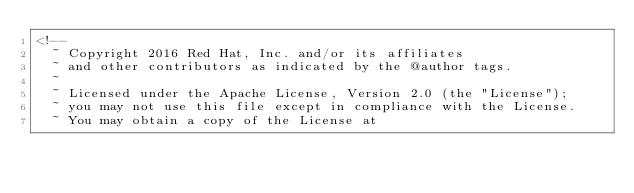<code> <loc_0><loc_0><loc_500><loc_500><_XML_><!--
  ~ Copyright 2016 Red Hat, Inc. and/or its affiliates
  ~ and other contributors as indicated by the @author tags.
  ~
  ~ Licensed under the Apache License, Version 2.0 (the "License");
  ~ you may not use this file except in compliance with the License.
  ~ You may obtain a copy of the License at</code> 